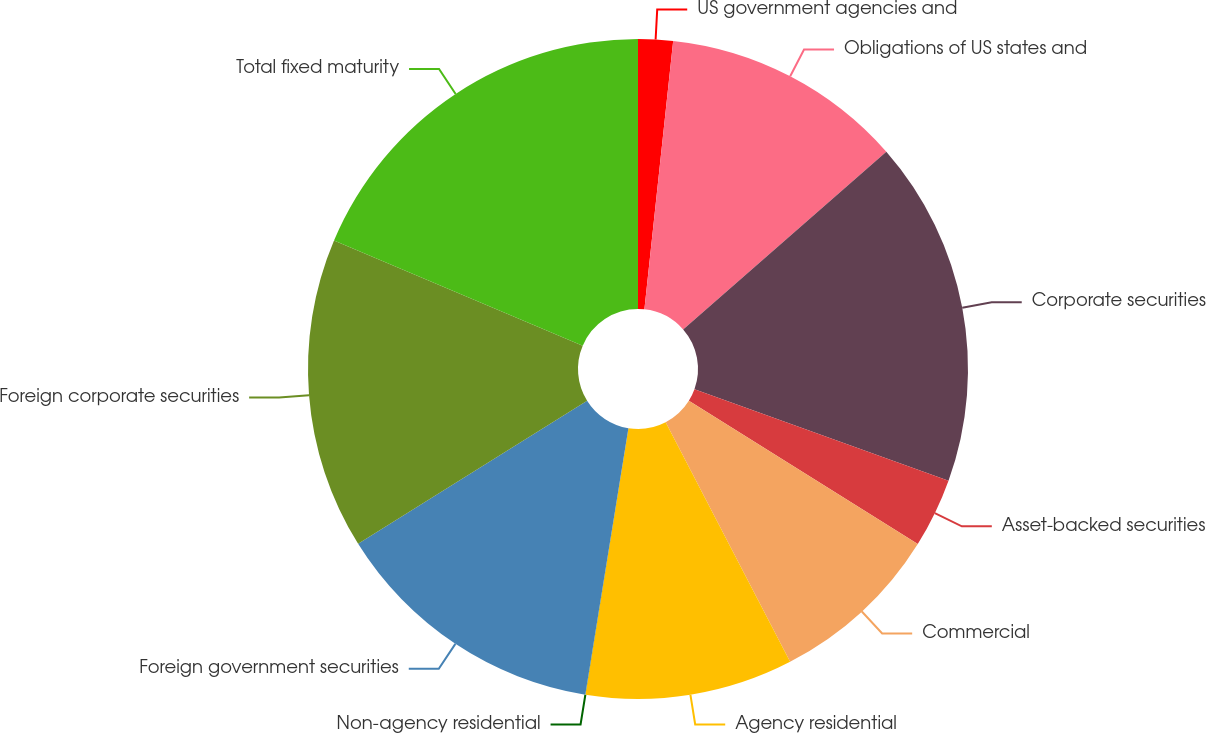Convert chart to OTSL. <chart><loc_0><loc_0><loc_500><loc_500><pie_chart><fcel>US government agencies and<fcel>Obligations of US states and<fcel>Corporate securities<fcel>Asset-backed securities<fcel>Commercial<fcel>Agency residential<fcel>Non-agency residential<fcel>Foreign government securities<fcel>Foreign corporate securities<fcel>Total fixed maturity<nl><fcel>1.7%<fcel>11.86%<fcel>16.94%<fcel>3.4%<fcel>8.48%<fcel>10.17%<fcel>0.01%<fcel>13.56%<fcel>15.25%<fcel>18.64%<nl></chart> 